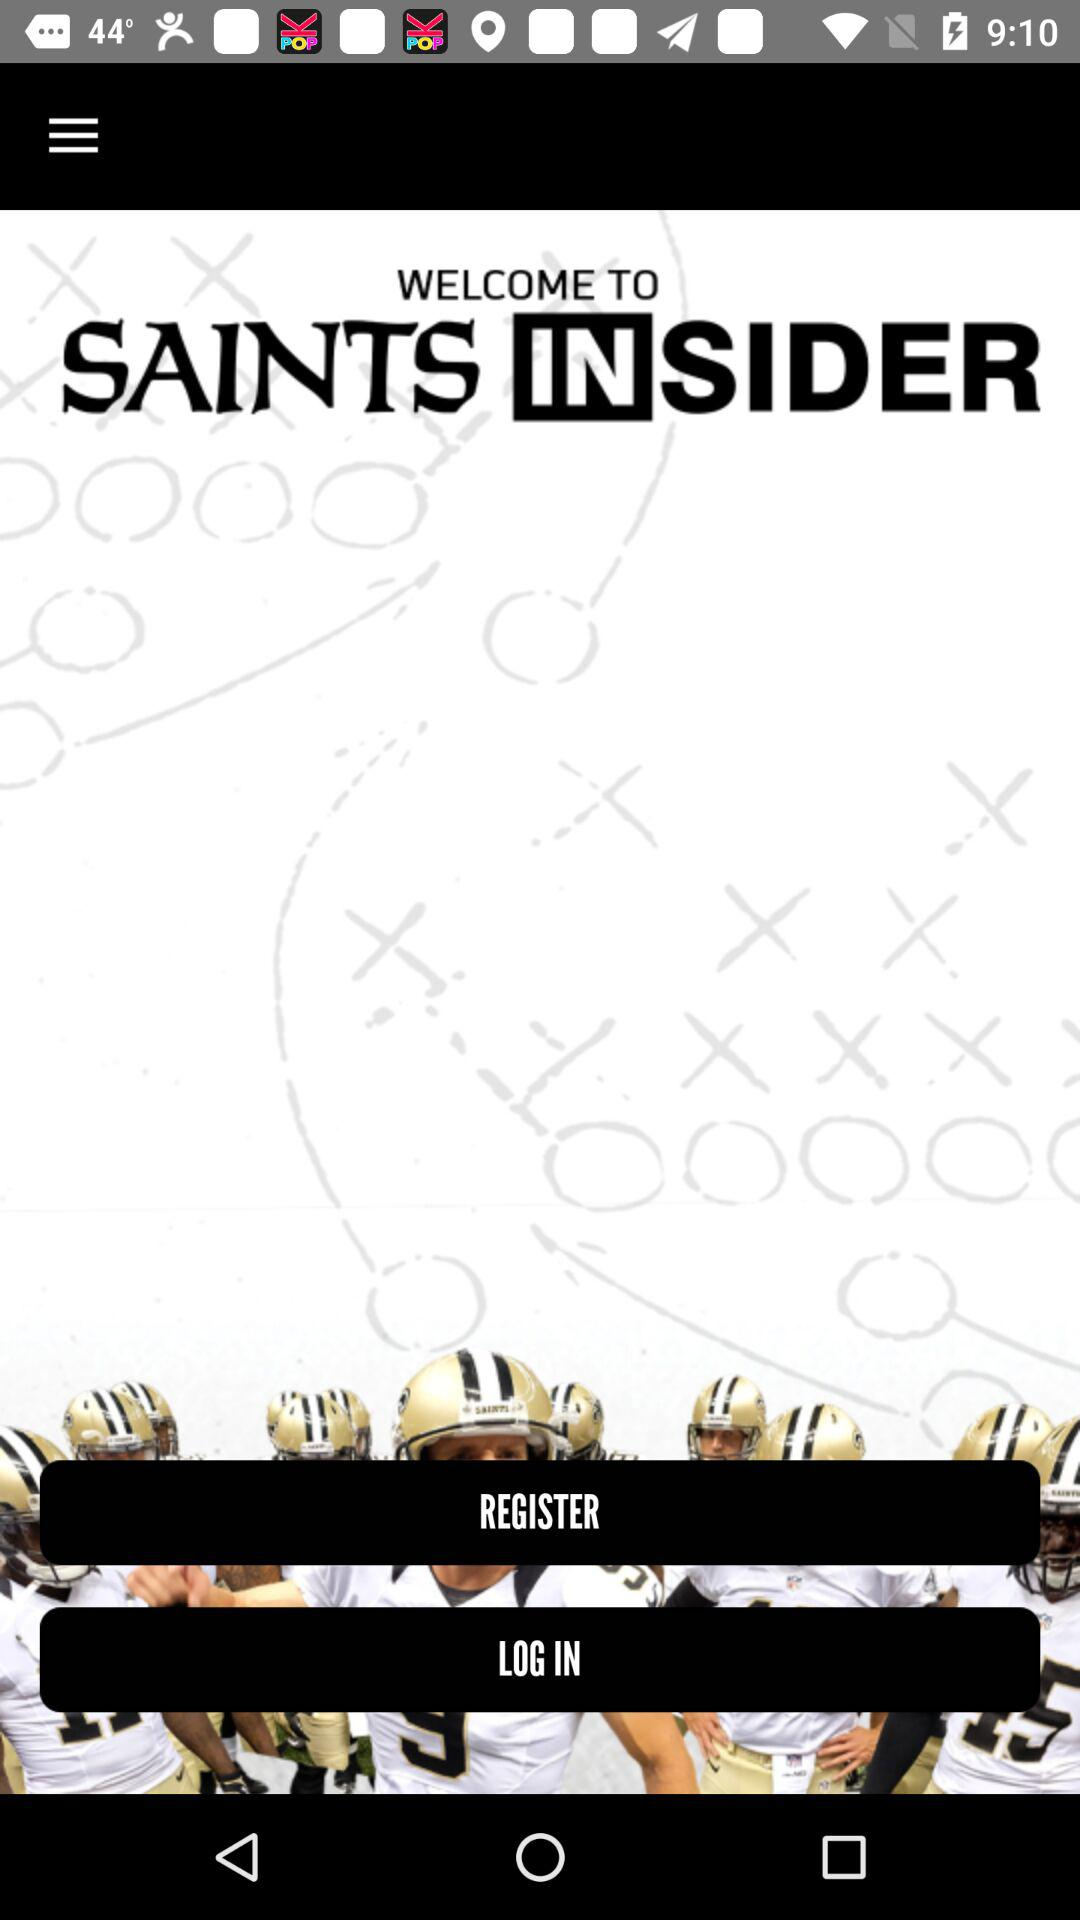What is the name of the application? The name of the application is "SAINTS INSIDER". 